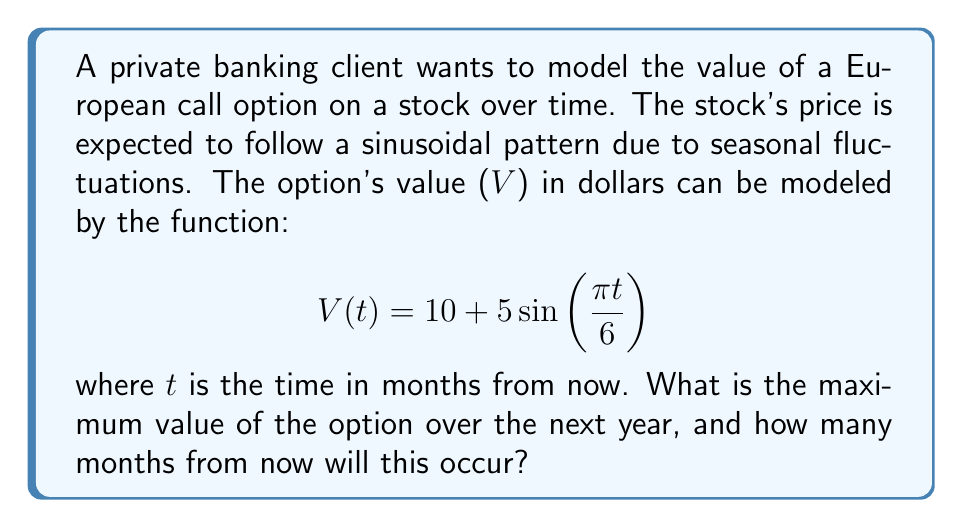Teach me how to tackle this problem. To solve this problem, we need to follow these steps:

1) The maximum value of the option will occur when the sine function reaches its peak value of 1. This is because the amplitude of the sine wave is 5, and it's centered around 10.

2) To find when $\sin(\frac{\pi t}{6})$ equals 1, we need to solve:

   $$\frac{\pi t}{6} = \frac{\pi}{2} + 2\pi n$$, where n is any integer.

3) Solving for t:

   $$t = 3 + 12n$$, where n is any integer.

4) Since we're only concerned with the next year (12 months), n must be 0.

5) Therefore, the maximum value will occur when t = 3 months.

6) To calculate the maximum value:

   $$V(3) = 10 + 5\sin(\frac{\pi \cdot 3}{6}) = 10 + 5\sin(\frac{\pi}{2}) = 10 + 5 \cdot 1 = 15$$

Thus, the maximum value is $15, occurring 3 months from now.
Answer: $15, 3 months 